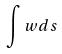<formula> <loc_0><loc_0><loc_500><loc_500>\int w d s</formula> 